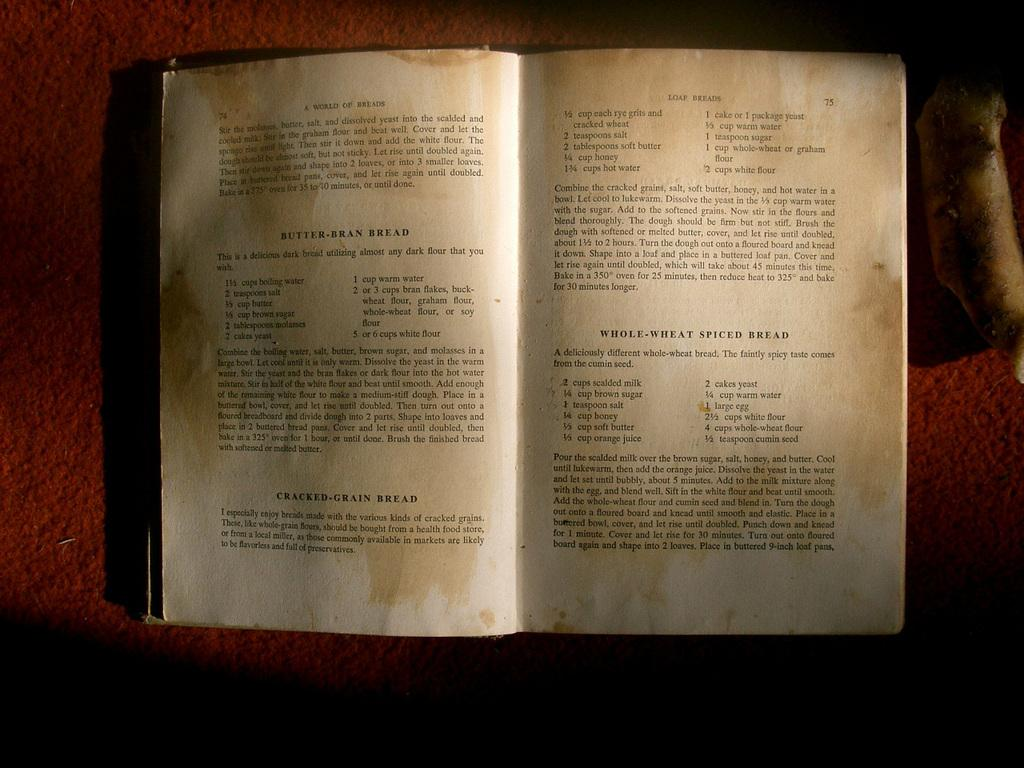What is the main object in the image? There is an open book in the image. What can be seen on the pages of the open book? The open book has text on it. What type of calculator is being used to solve the equations in the image? There is no calculator present in the image; it only features an open book with text on its pages. 